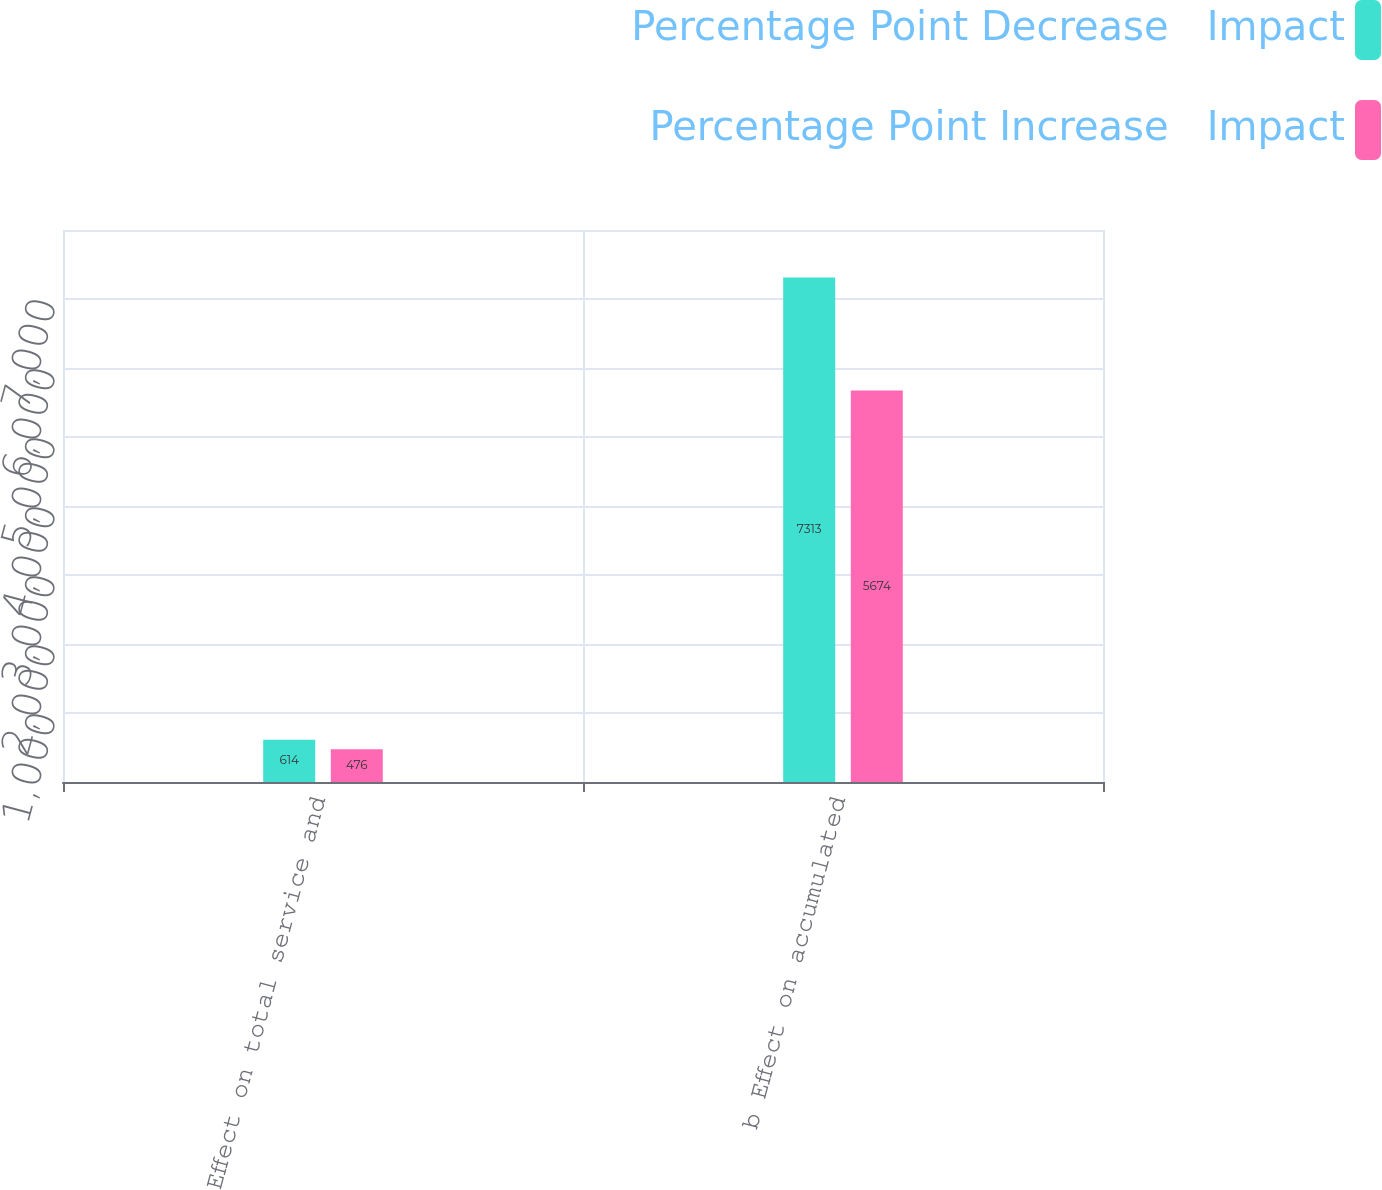Convert chart to OTSL. <chart><loc_0><loc_0><loc_500><loc_500><stacked_bar_chart><ecel><fcel>a Effect on total service and<fcel>b Effect on accumulated<nl><fcel>Percentage Point Decrease   Impact<fcel>614<fcel>7313<nl><fcel>Percentage Point Increase   Impact<fcel>476<fcel>5674<nl></chart> 